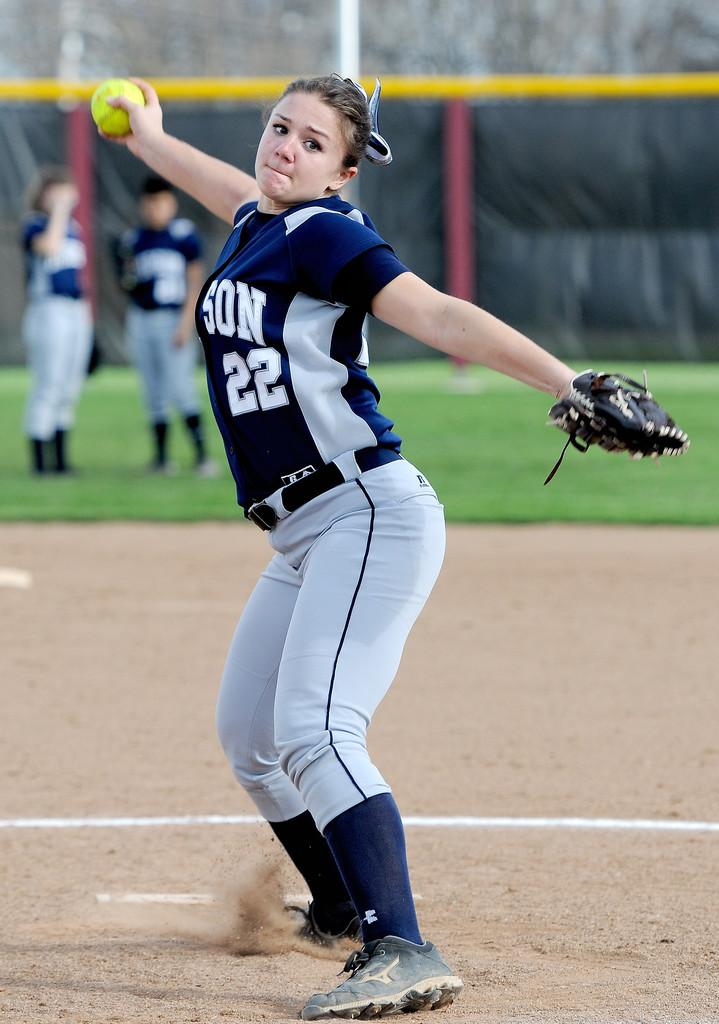Provide a one-sentence caption for the provided image. A young girl in a blue and gray softball uniform with the number 22 on it about to throw a ball. 